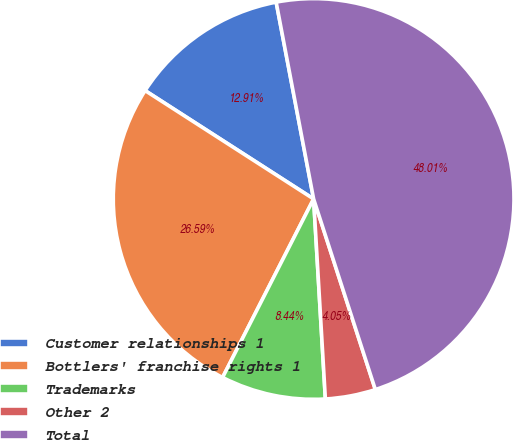Convert chart. <chart><loc_0><loc_0><loc_500><loc_500><pie_chart><fcel>Customer relationships 1<fcel>Bottlers' franchise rights 1<fcel>Trademarks<fcel>Other 2<fcel>Total<nl><fcel>12.91%<fcel>26.59%<fcel>8.44%<fcel>4.05%<fcel>48.01%<nl></chart> 